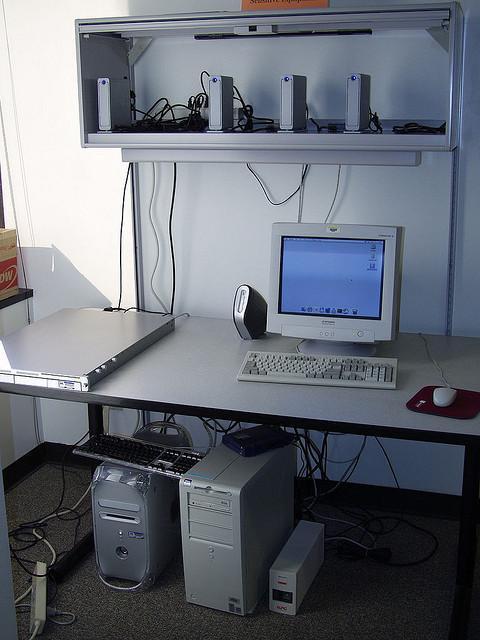How many monitors are there?
Give a very brief answer. 1. How many tvs are in the photo?
Give a very brief answer. 1. How many boats are visible?
Give a very brief answer. 0. 